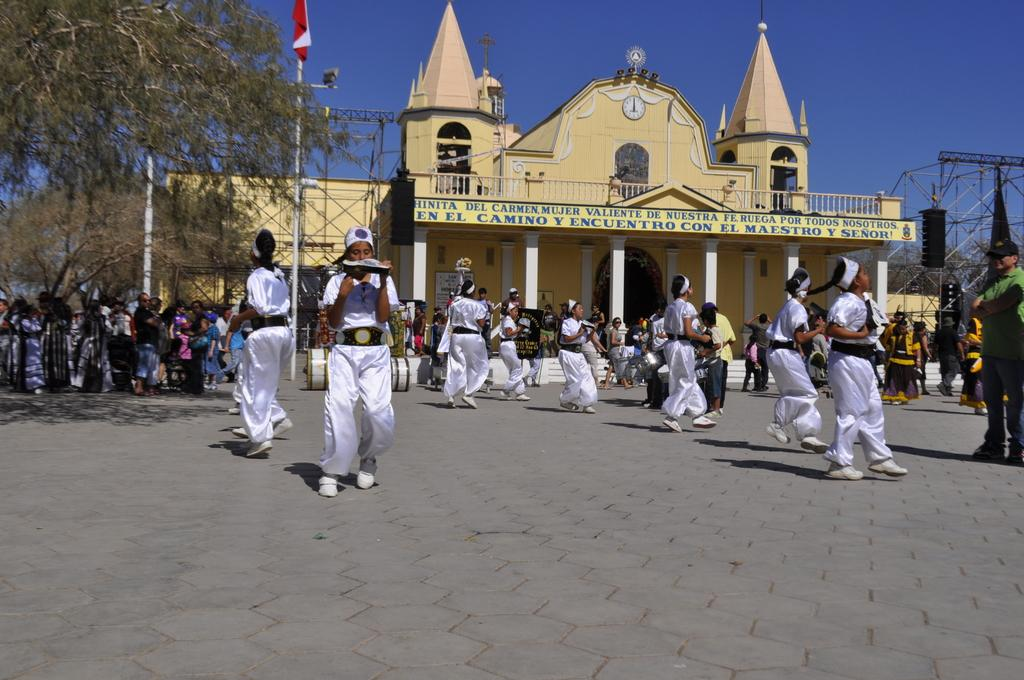What are the people in the image doing? There is a group of people walking on the ground, and another group of people standing under a tree. What can be seen in the background of the image? There is a building visible in the image. Can you describe any other elements present in the image? There are other unspecified elements present in the image. What type of cloth is being used to create motion in the image? There is no cloth or motion present in the image; it features people walking and standing, and a building in the background. 